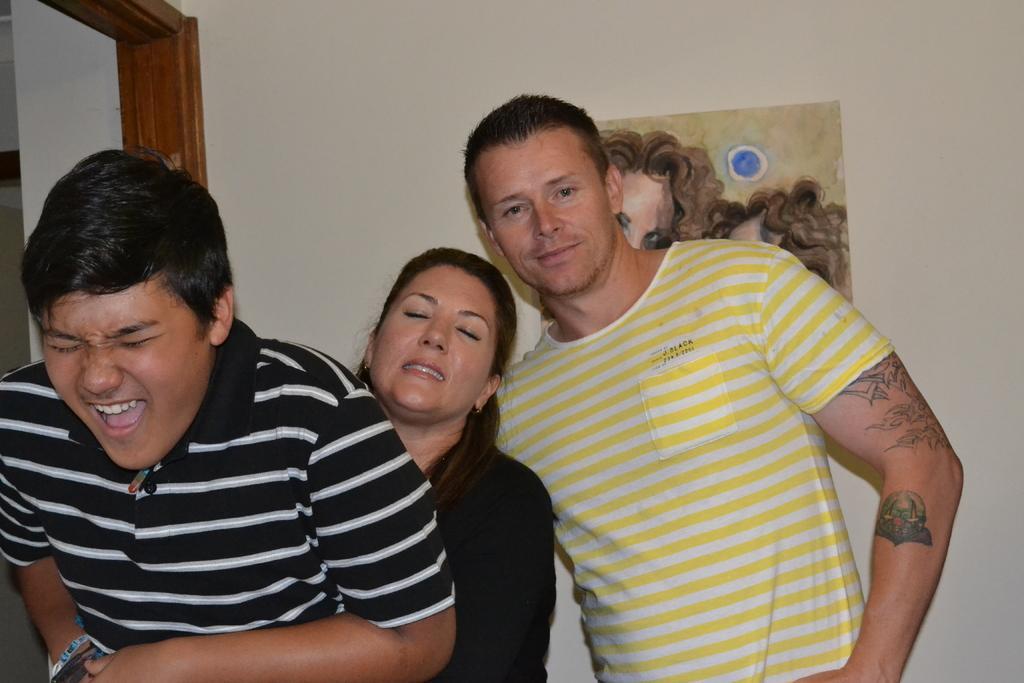Please provide a concise description of this image. In this image there are three persons standing,in the background there is a wall, for that wall there is a painting and a door. 